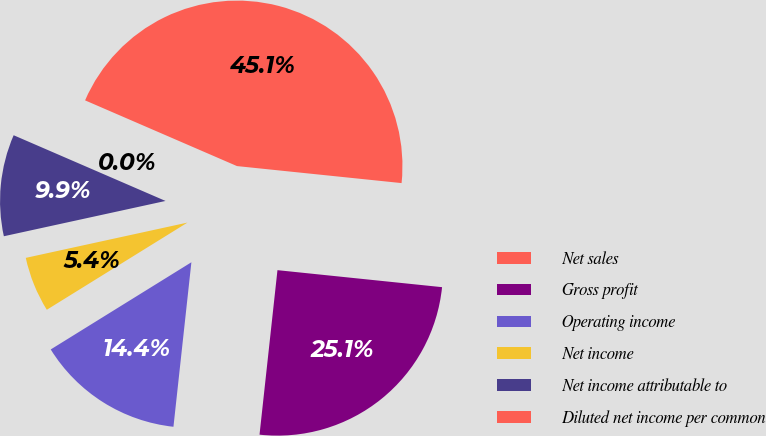Convert chart to OTSL. <chart><loc_0><loc_0><loc_500><loc_500><pie_chart><fcel>Net sales<fcel>Gross profit<fcel>Operating income<fcel>Net income<fcel>Net income attributable to<fcel>Diluted net income per common<nl><fcel>45.14%<fcel>25.09%<fcel>14.44%<fcel>5.41%<fcel>9.92%<fcel>0.0%<nl></chart> 